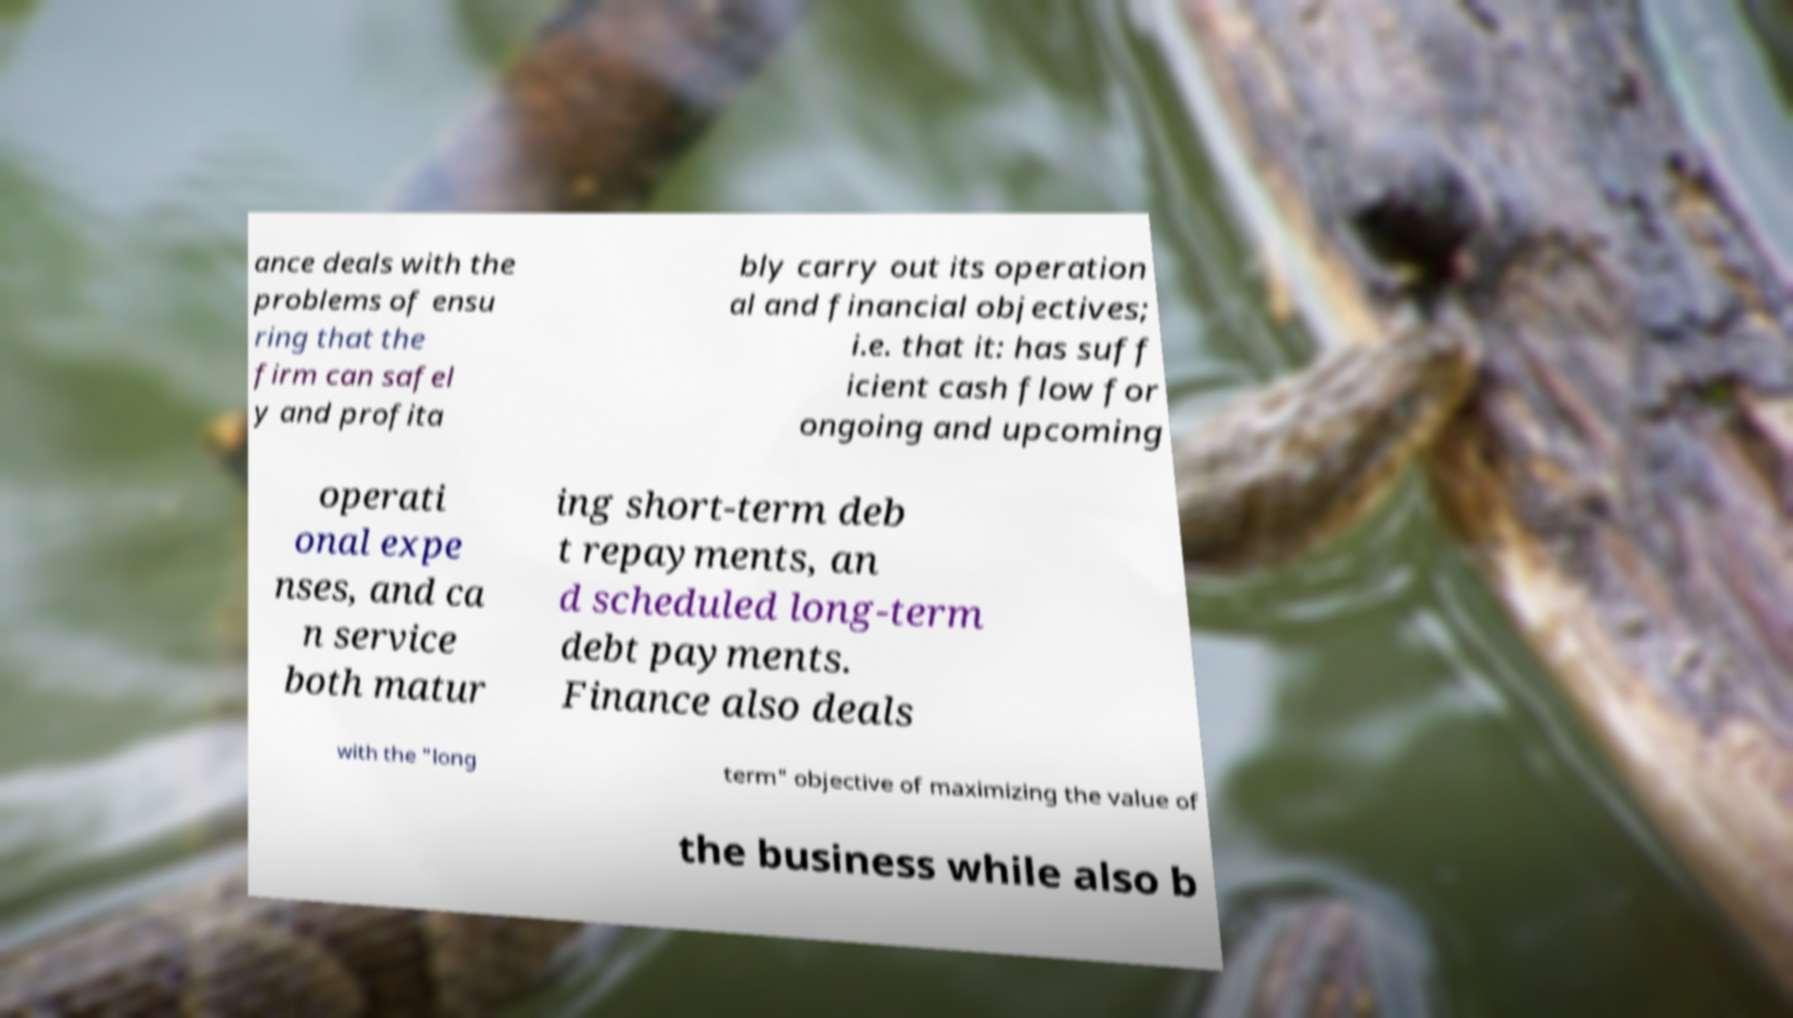What messages or text are displayed in this image? I need them in a readable, typed format. ance deals with the problems of ensu ring that the firm can safel y and profita bly carry out its operation al and financial objectives; i.e. that it: has suff icient cash flow for ongoing and upcoming operati onal expe nses, and ca n service both matur ing short-term deb t repayments, an d scheduled long-term debt payments. Finance also deals with the "long term" objective of maximizing the value of the business while also b 